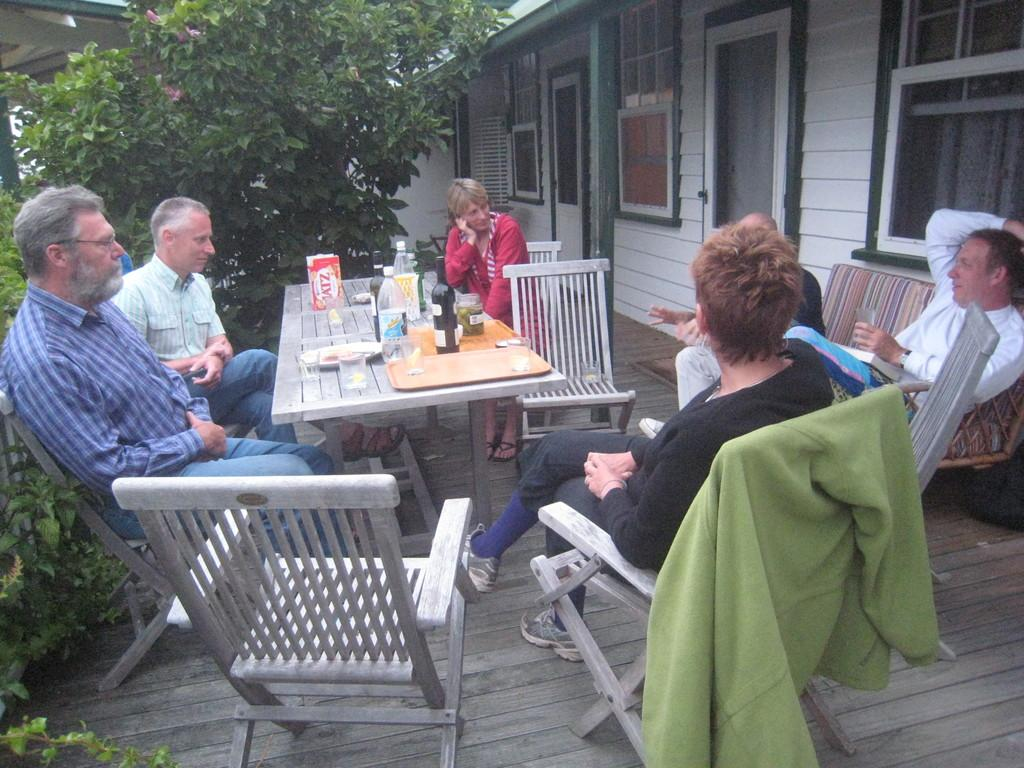What are the people in the image doing? There is a group of people sitting on chairs in the image. What can be seen on the table in the image? There is a box, bottles, a plate, and other objects on the table in the image. What is the natural element visible in the image? There is a tree in the image. What man-made structure is visible in the image? There is a house in the image. What statement is being exchanged between the people in the image? There is no information about a statement being exchanged between the people in the image. 